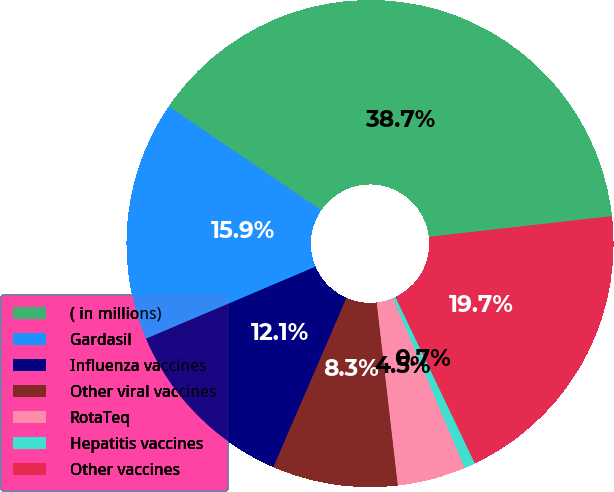<chart> <loc_0><loc_0><loc_500><loc_500><pie_chart><fcel>( in millions)<fcel>Gardasil<fcel>Influenza vaccines<fcel>Other viral vaccines<fcel>RotaTeq<fcel>Hepatitis vaccines<fcel>Other vaccines<nl><fcel>38.69%<fcel>15.91%<fcel>12.12%<fcel>8.32%<fcel>4.53%<fcel>0.73%<fcel>19.71%<nl></chart> 